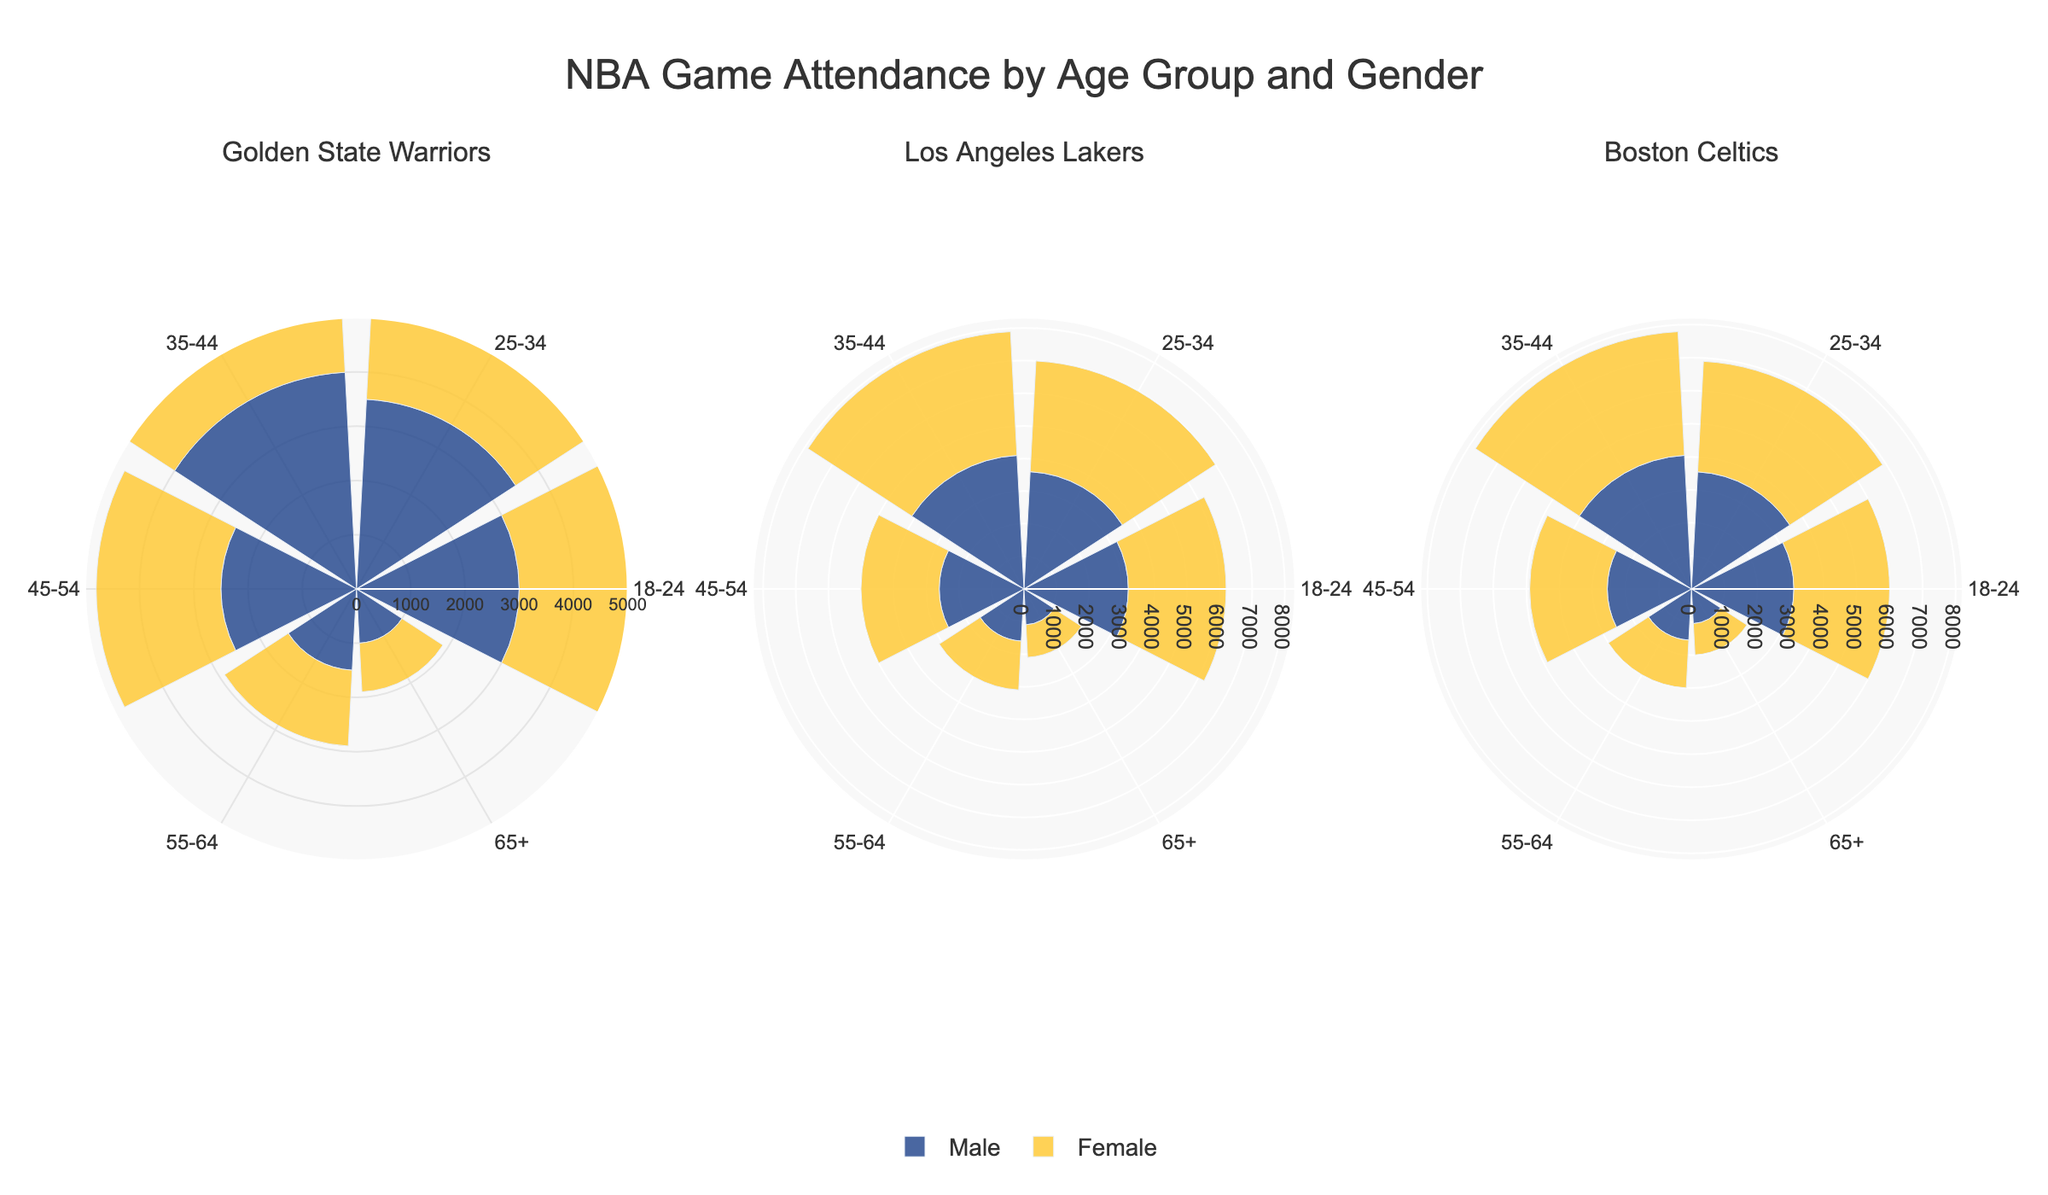What is the total attendance for the Golden State Warriors? To find the total attendance, sum the number of attendees from all age groups and both genders for the Golden State Warriors. The sum is 3000 (M, 18-24) + 2800 (F, 18-24) + 3500 (M, 25-34) + 3300 (F, 25-34) + 4000 (M, 35-44) + 3700 (F, 35-44) + 2500 (M, 45-54) + 2300 (F, 45-54) + 1500 (M, 55-64) + 1400 (F, 55-64) + 1000 (M, 65+) + 900 (F, 65+).
Answer: 32900 Which team has the highest attendance for the age group 35-44? Compare the attendance for age group 35-44 across all teams. The attendance for the Golden State Warriors is 4000 (M) + 3700 (F), Los Angeles Lakers is 4100 (M) + 3800 (F), and Boston Celtics is 4050 (M) + 3750 (F). The highest attendance is for the Los Angeles Lakers.
Answer: Los Angeles Lakers What's the attendance difference between male and female fans aged 25-34 for the Boston Celtics? Find the attendance for males and females aged 25-34 for the Boston Celtics and compute the difference: 3550 (M) - 3350 (F) = 200.
Answer: 200 What is the gender with higher attendance for each team? Compare the total attendance of males and females for each team. For the Golden State Warriors: 3000 + 3500 + 4000 + 2500 + 1500 + 1000 (M) vs. 2800 + 3300 + 3700 + 2300 + 1400 + 900 (F). For the Los Angeles Lakers: 3200 + 3600 + 4100 + 2600 + 1600 + 1100 (M) vs. 3000 + 3400 + 3800 + 2400 + 1500 + 1000 (F). For the Boston Celtics: 3100 + 3550 + 4050 + 2550 + 1550 + 1050 (M) vs. 2900 + 3350 + 3750 + 2350 + 1450 + 950 (F). Males have higher attendance for all teams.
Answer: Males Which age group has the lowest attendance for the Golden State Warriors? Compare the attendance of all age groups for the Golden State Warriors. The attendance is: 3000 (M, 18-24) + 2800 (F, 18-24), 3500 (M, 25-34) + 3300 (F, 25-34), 4000 (M, 35-44) + 3700 (F, 35-44), 2500 (M, 45-54) + 2300 (F, 45-54), 1500 (M, 55-64) + 1400 (F, 55-64), 1000 (M, 65+) + 900 (F, 65+). The 65+ age group has the lowest attendance.
Answer: 65+ What's the average attendance for female fans of the Los Angeles Lakers? Find the total attendance for female fans of the Los Angeles Lakers and divide by the number of age groups: (3000 + 3400 + 3800 + 2400 + 1500 + 1000) / 6 = 2516.67.
Answer: 2516.67 Does the attendance for the 18-24 age group show a significant difference across teams? Compare the attendance for the 18-24 age group across all three teams: Golden State Warriors (3000 M, 2800 F), Los Angeles Lakers (3200 M, 3000 F), Boston Celtics (3100 M, 2900 F). The differences are not significant as they are close in value.
Answer: No significant difference Which team has a higher male attendance for the age group 55-64, and by how much? Compare the male attendance for the 55-64 age group for each team: Golden State Warriors (1500), Los Angeles Lakers (1600), Boston Celtics (1550). Los Angeles Lakers have the highest attendance. The difference with Boston Celtics, the next highest, is 1600 - 1550 = 50.
Answer: Los Angeles Lakers, 50 What's the total attendance for the Boston Celtics? To find the total attendance, sum the number of attendees from all age groups and both genders for the Boston Celtics. The sum is 3100 (M, 18-24) + 2900 (F, 18-24) + 3550 (M, 25-34) + 3350 (F, 25-34) + 4050 (M, 35-44) + 3750 (F, 35-44) + 2550 (M, 45-54) + 2350 (F, 45-54) + 1550 (M, 55-64) + 1450 (F, 55-64) + 1050 (M, 65+) + 950 (F, 65+).
Answer: 33300 